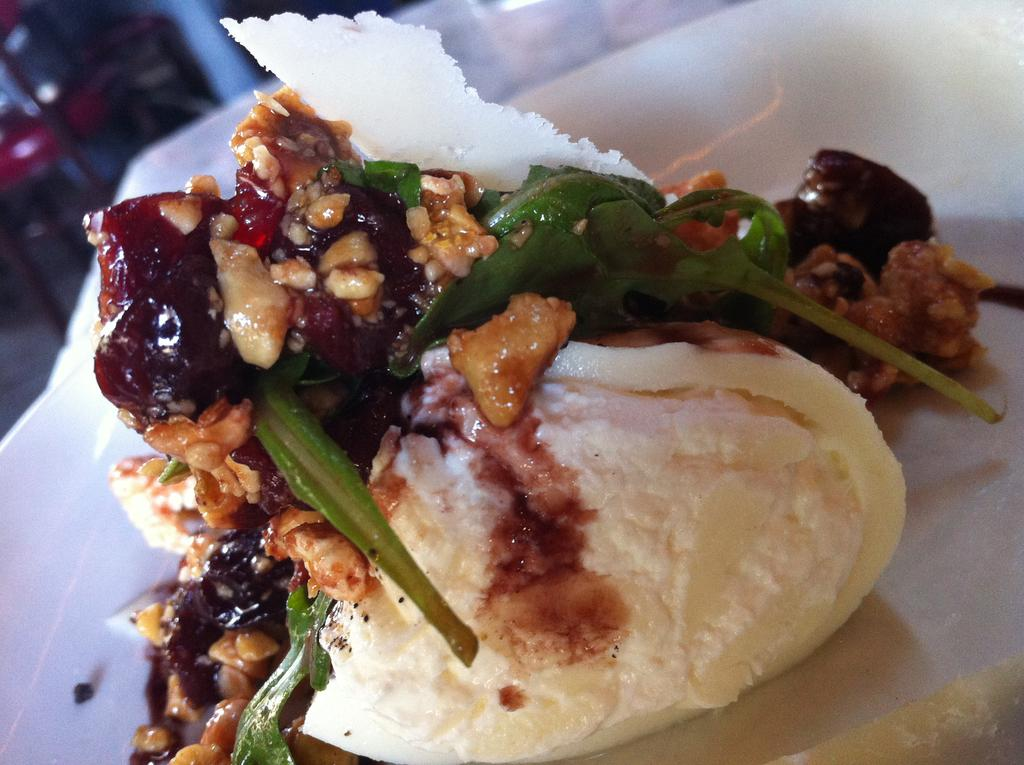What type of food is featured in the image? There is a dessert in the image. How is the dessert presented? The dessert is served on a plate. What caption is written on the dessert in the image? There is no caption written on the dessert in the image. Can you spot a toad hiding among the dessert ingredients? There is no toad present in the image. 